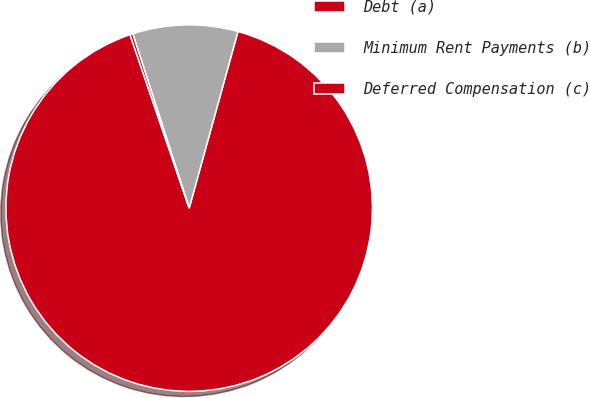Convert chart. <chart><loc_0><loc_0><loc_500><loc_500><pie_chart><fcel>Debt (a)<fcel>Minimum Rent Payments (b)<fcel>Deferred Compensation (c)<nl><fcel>90.48%<fcel>9.27%<fcel>0.25%<nl></chart> 